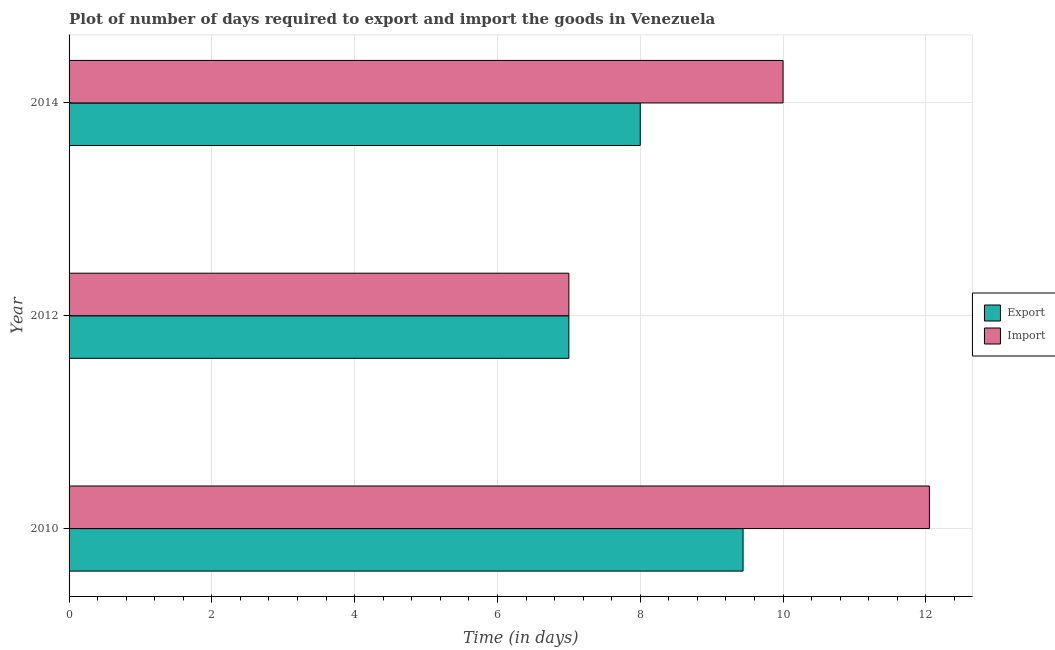What is the label of the 1st group of bars from the top?
Your answer should be compact. 2014. In how many cases, is the number of bars for a given year not equal to the number of legend labels?
Give a very brief answer. 0. Across all years, what is the maximum time required to export?
Give a very brief answer. 9.44. Across all years, what is the minimum time required to export?
Offer a very short reply. 7. In which year was the time required to export maximum?
Your answer should be compact. 2010. In which year was the time required to export minimum?
Keep it short and to the point. 2012. What is the total time required to export in the graph?
Offer a terse response. 24.44. What is the difference between the time required to export in 2010 and that in 2012?
Make the answer very short. 2.44. What is the difference between the time required to export in 2010 and the time required to import in 2012?
Provide a short and direct response. 2.44. What is the average time required to import per year?
Offer a very short reply. 9.68. In the year 2010, what is the difference between the time required to export and time required to import?
Ensure brevity in your answer.  -2.61. In how many years, is the time required to import greater than 3.2 days?
Ensure brevity in your answer.  3. Is the time required to export in 2010 less than that in 2014?
Give a very brief answer. No. Is the difference between the time required to import in 2012 and 2014 greater than the difference between the time required to export in 2012 and 2014?
Give a very brief answer. No. What is the difference between the highest and the second highest time required to import?
Offer a very short reply. 2.05. What is the difference between the highest and the lowest time required to export?
Offer a terse response. 2.44. Is the sum of the time required to export in 2010 and 2012 greater than the maximum time required to import across all years?
Ensure brevity in your answer.  Yes. What does the 1st bar from the top in 2014 represents?
Your answer should be very brief. Import. What does the 1st bar from the bottom in 2012 represents?
Offer a terse response. Export. How many bars are there?
Make the answer very short. 6. Are all the bars in the graph horizontal?
Offer a terse response. Yes. What is the difference between two consecutive major ticks on the X-axis?
Ensure brevity in your answer.  2. Are the values on the major ticks of X-axis written in scientific E-notation?
Your response must be concise. No. Does the graph contain any zero values?
Give a very brief answer. No. Does the graph contain grids?
Offer a very short reply. Yes. How are the legend labels stacked?
Offer a very short reply. Vertical. What is the title of the graph?
Offer a very short reply. Plot of number of days required to export and import the goods in Venezuela. Does "Investment in Telecom" appear as one of the legend labels in the graph?
Give a very brief answer. No. What is the label or title of the X-axis?
Your response must be concise. Time (in days). What is the label or title of the Y-axis?
Offer a terse response. Year. What is the Time (in days) in Export in 2010?
Ensure brevity in your answer.  9.44. What is the Time (in days) of Import in 2010?
Ensure brevity in your answer.  12.05. What is the Time (in days) in Export in 2012?
Your answer should be compact. 7. What is the Time (in days) of Export in 2014?
Make the answer very short. 8. What is the Time (in days) in Import in 2014?
Your response must be concise. 10. Across all years, what is the maximum Time (in days) of Export?
Offer a very short reply. 9.44. Across all years, what is the maximum Time (in days) in Import?
Your answer should be compact. 12.05. Across all years, what is the minimum Time (in days) in Export?
Give a very brief answer. 7. What is the total Time (in days) of Export in the graph?
Ensure brevity in your answer.  24.44. What is the total Time (in days) of Import in the graph?
Offer a terse response. 29.05. What is the difference between the Time (in days) of Export in 2010 and that in 2012?
Offer a very short reply. 2.44. What is the difference between the Time (in days) of Import in 2010 and that in 2012?
Make the answer very short. 5.05. What is the difference between the Time (in days) of Export in 2010 and that in 2014?
Provide a short and direct response. 1.44. What is the difference between the Time (in days) of Import in 2010 and that in 2014?
Your answer should be compact. 2.05. What is the difference between the Time (in days) in Export in 2012 and that in 2014?
Provide a short and direct response. -1. What is the difference between the Time (in days) of Import in 2012 and that in 2014?
Offer a terse response. -3. What is the difference between the Time (in days) in Export in 2010 and the Time (in days) in Import in 2012?
Provide a short and direct response. 2.44. What is the difference between the Time (in days) in Export in 2010 and the Time (in days) in Import in 2014?
Provide a succinct answer. -0.56. What is the average Time (in days) of Export per year?
Make the answer very short. 8.15. What is the average Time (in days) of Import per year?
Offer a very short reply. 9.68. In the year 2010, what is the difference between the Time (in days) of Export and Time (in days) of Import?
Give a very brief answer. -2.61. In the year 2012, what is the difference between the Time (in days) in Export and Time (in days) in Import?
Provide a short and direct response. 0. In the year 2014, what is the difference between the Time (in days) of Export and Time (in days) of Import?
Keep it short and to the point. -2. What is the ratio of the Time (in days) in Export in 2010 to that in 2012?
Make the answer very short. 1.35. What is the ratio of the Time (in days) in Import in 2010 to that in 2012?
Make the answer very short. 1.72. What is the ratio of the Time (in days) in Export in 2010 to that in 2014?
Your response must be concise. 1.18. What is the ratio of the Time (in days) of Import in 2010 to that in 2014?
Your answer should be very brief. 1.21. What is the ratio of the Time (in days) of Import in 2012 to that in 2014?
Keep it short and to the point. 0.7. What is the difference between the highest and the second highest Time (in days) in Export?
Ensure brevity in your answer.  1.44. What is the difference between the highest and the second highest Time (in days) of Import?
Your response must be concise. 2.05. What is the difference between the highest and the lowest Time (in days) in Export?
Provide a succinct answer. 2.44. What is the difference between the highest and the lowest Time (in days) in Import?
Your response must be concise. 5.05. 